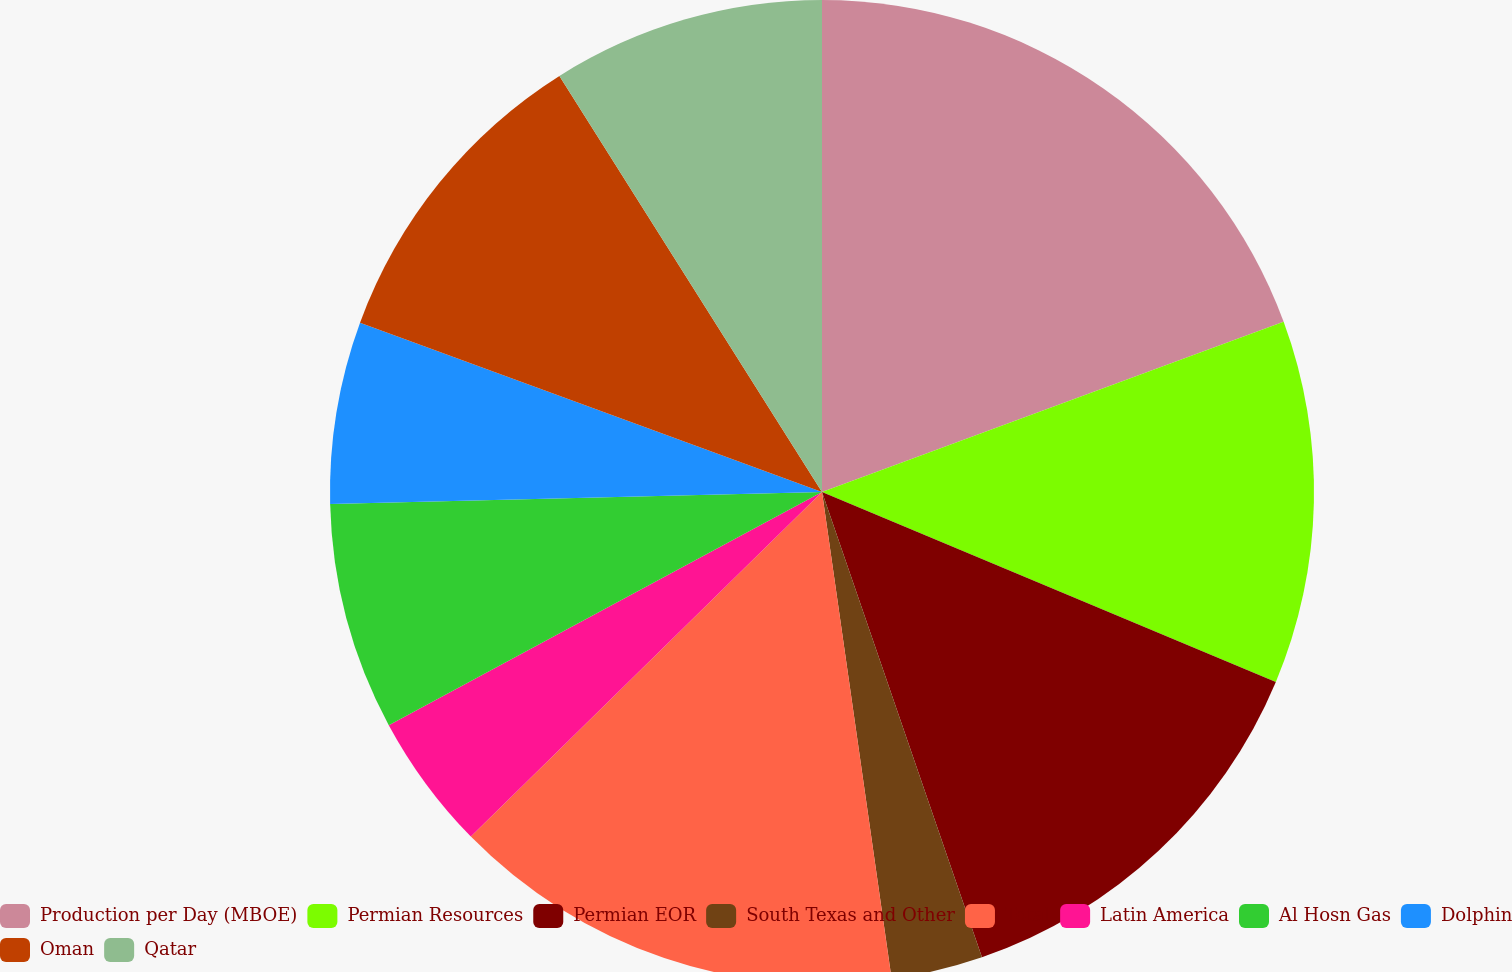Convert chart to OTSL. <chart><loc_0><loc_0><loc_500><loc_500><pie_chart><fcel>Production per Day (MBOE)<fcel>Permian Resources<fcel>Permian EOR<fcel>South Texas and Other<fcel>Total<fcel>Latin America<fcel>Al Hosn Gas<fcel>Dolphin<fcel>Oman<fcel>Qatar<nl><fcel>19.38%<fcel>11.93%<fcel>13.42%<fcel>3.01%<fcel>14.91%<fcel>4.49%<fcel>7.47%<fcel>5.98%<fcel>10.45%<fcel>8.96%<nl></chart> 